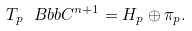<formula> <loc_0><loc_0><loc_500><loc_500>T _ { p } \ B b b { C } ^ { n + 1 } = H _ { p } \oplus \pi _ { p } .</formula> 